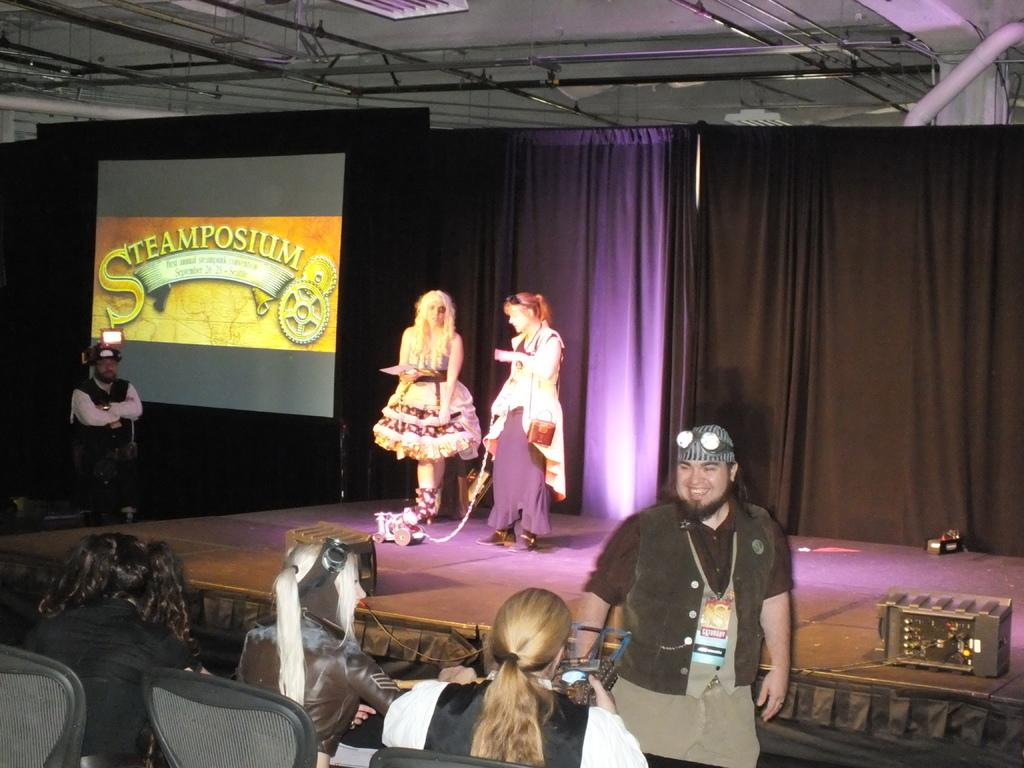Who or what can be seen in the image? There are people in the image. What type of window treatment is present in the image? There are curtains in the image. What is the primary object in the background of the image? There is a screen in the image. What type of furniture is visible in the image? There is a chair in the image. What type of oatmeal is being served in the image? There is no oatmeal present in the image. Can you tell me who won the argument in the image? There is no argument present in the image. 